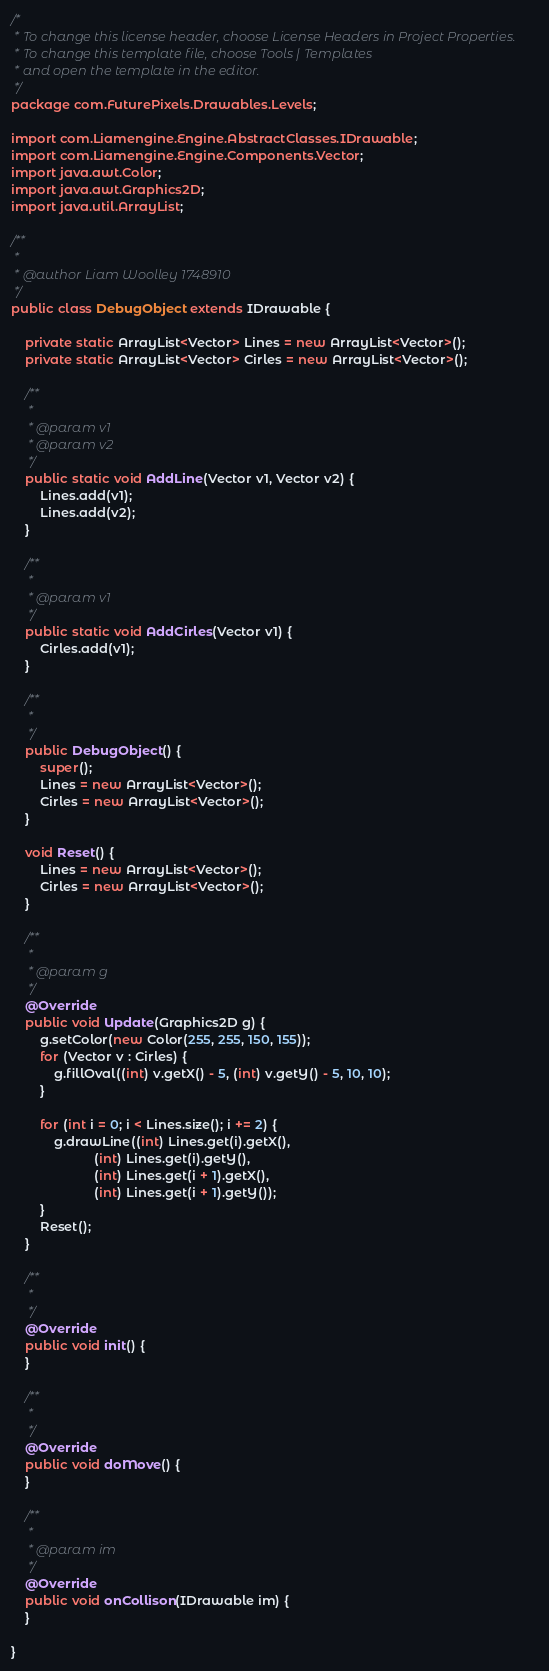<code> <loc_0><loc_0><loc_500><loc_500><_Java_>/*
 * To change this license header, choose License Headers in Project Properties.
 * To change this template file, choose Tools | Templates
 * and open the template in the editor.
 */
package com.FuturePixels.Drawables.Levels;

import com.Liamengine.Engine.AbstractClasses.IDrawable;
import com.Liamengine.Engine.Components.Vector;
import java.awt.Color;
import java.awt.Graphics2D;
import java.util.ArrayList;

/**
 *
 * @author Liam Woolley 1748910
 */
public class DebugObject extends IDrawable {

    private static ArrayList<Vector> Lines = new ArrayList<Vector>();
    private static ArrayList<Vector> Cirles = new ArrayList<Vector>();

    /**
     *
     * @param v1
     * @param v2
     */
    public static void AddLine(Vector v1, Vector v2) {
        Lines.add(v1);
        Lines.add(v2);
    }

    /**
     *
     * @param v1
     */
    public static void AddCirles(Vector v1) {
        Cirles.add(v1);
    }

    /**
     *
     */
    public DebugObject() {
        super();
        Lines = new ArrayList<Vector>();
        Cirles = new ArrayList<Vector>();
    }

    void Reset() {
        Lines = new ArrayList<Vector>();
        Cirles = new ArrayList<Vector>();
    }

    /**
     *
     * @param g
     */
    @Override
    public void Update(Graphics2D g) {
        g.setColor(new Color(255, 255, 150, 155));
        for (Vector v : Cirles) {
            g.fillOval((int) v.getX() - 5, (int) v.getY() - 5, 10, 10);
        }

        for (int i = 0; i < Lines.size(); i += 2) {
            g.drawLine((int) Lines.get(i).getX(),
                       (int) Lines.get(i).getY(),
                       (int) Lines.get(i + 1).getX(),
                       (int) Lines.get(i + 1).getY());
        }
        Reset();
    }

    /**
     *
     */
    @Override
    public void init() {
    }

    /**
     *
     */
    @Override
    public void doMove() {
    }

    /**
     *
     * @param im
     */
    @Override
    public void onCollison(IDrawable im) {
    }

}
</code> 